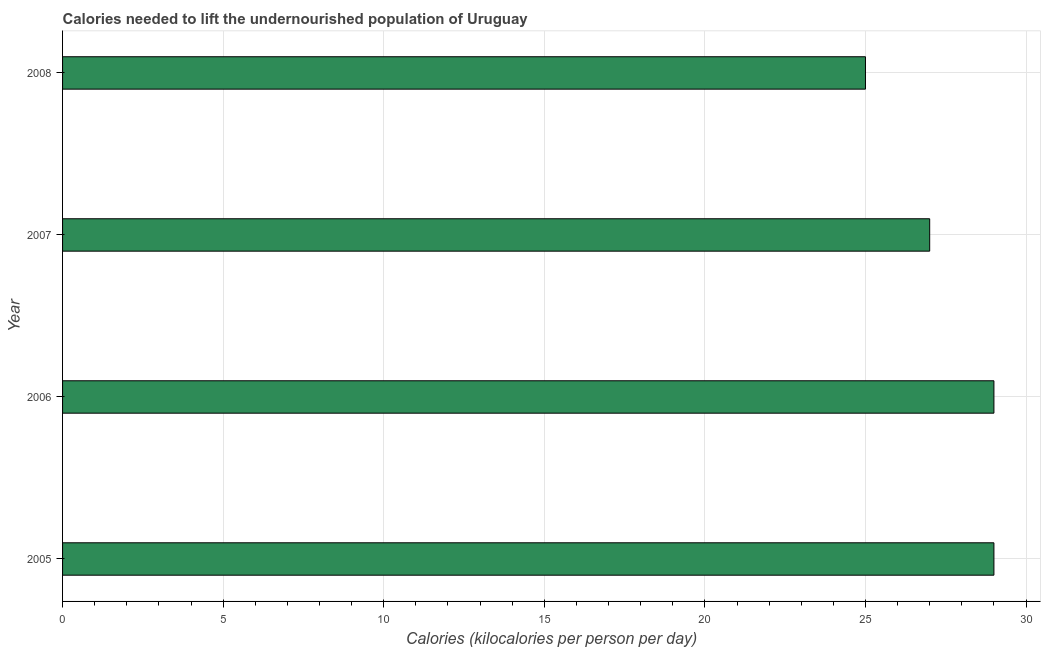Does the graph contain grids?
Provide a short and direct response. Yes. What is the title of the graph?
Your response must be concise. Calories needed to lift the undernourished population of Uruguay. What is the label or title of the X-axis?
Your response must be concise. Calories (kilocalories per person per day). What is the label or title of the Y-axis?
Your response must be concise. Year. Across all years, what is the maximum depth of food deficit?
Your answer should be very brief. 29. Across all years, what is the minimum depth of food deficit?
Make the answer very short. 25. In which year was the depth of food deficit maximum?
Your answer should be very brief. 2005. In which year was the depth of food deficit minimum?
Provide a short and direct response. 2008. What is the sum of the depth of food deficit?
Offer a terse response. 110. What is the difference between the depth of food deficit in 2005 and 2007?
Offer a terse response. 2. What is the average depth of food deficit per year?
Your answer should be compact. 27. In how many years, is the depth of food deficit greater than 27 kilocalories?
Provide a short and direct response. 2. What is the ratio of the depth of food deficit in 2007 to that in 2008?
Your answer should be very brief. 1.08. What is the difference between the highest and the second highest depth of food deficit?
Keep it short and to the point. 0. How many bars are there?
Your response must be concise. 4. Are all the bars in the graph horizontal?
Provide a succinct answer. Yes. How many years are there in the graph?
Ensure brevity in your answer.  4. What is the difference between two consecutive major ticks on the X-axis?
Ensure brevity in your answer.  5. What is the Calories (kilocalories per person per day) in 2005?
Offer a very short reply. 29. What is the Calories (kilocalories per person per day) of 2006?
Offer a very short reply. 29. What is the Calories (kilocalories per person per day) of 2007?
Offer a terse response. 27. What is the difference between the Calories (kilocalories per person per day) in 2005 and 2008?
Your answer should be compact. 4. What is the difference between the Calories (kilocalories per person per day) in 2006 and 2007?
Offer a terse response. 2. What is the difference between the Calories (kilocalories per person per day) in 2007 and 2008?
Provide a succinct answer. 2. What is the ratio of the Calories (kilocalories per person per day) in 2005 to that in 2006?
Your answer should be compact. 1. What is the ratio of the Calories (kilocalories per person per day) in 2005 to that in 2007?
Your response must be concise. 1.07. What is the ratio of the Calories (kilocalories per person per day) in 2005 to that in 2008?
Your answer should be compact. 1.16. What is the ratio of the Calories (kilocalories per person per day) in 2006 to that in 2007?
Provide a succinct answer. 1.07. What is the ratio of the Calories (kilocalories per person per day) in 2006 to that in 2008?
Ensure brevity in your answer.  1.16. 